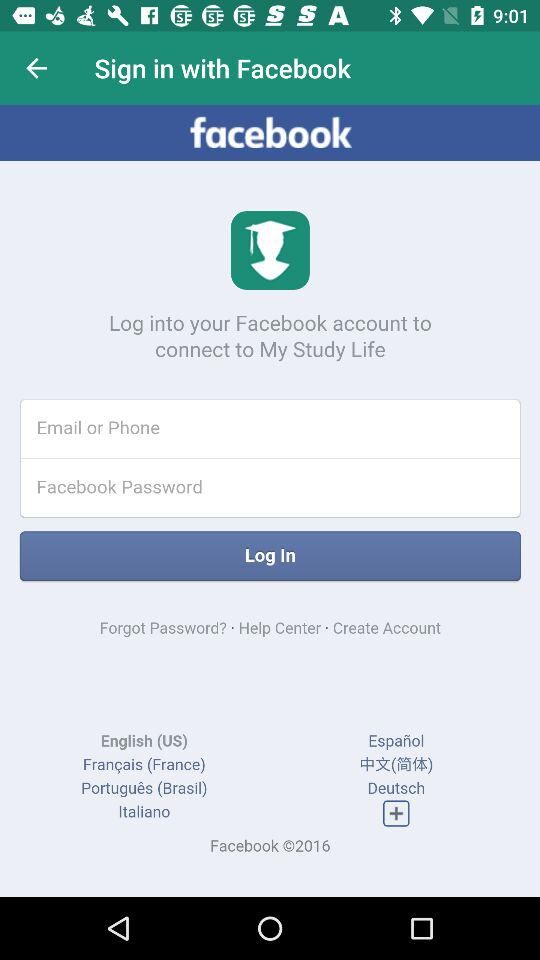What is the name of the application? The name of the application is "My Study Life". 